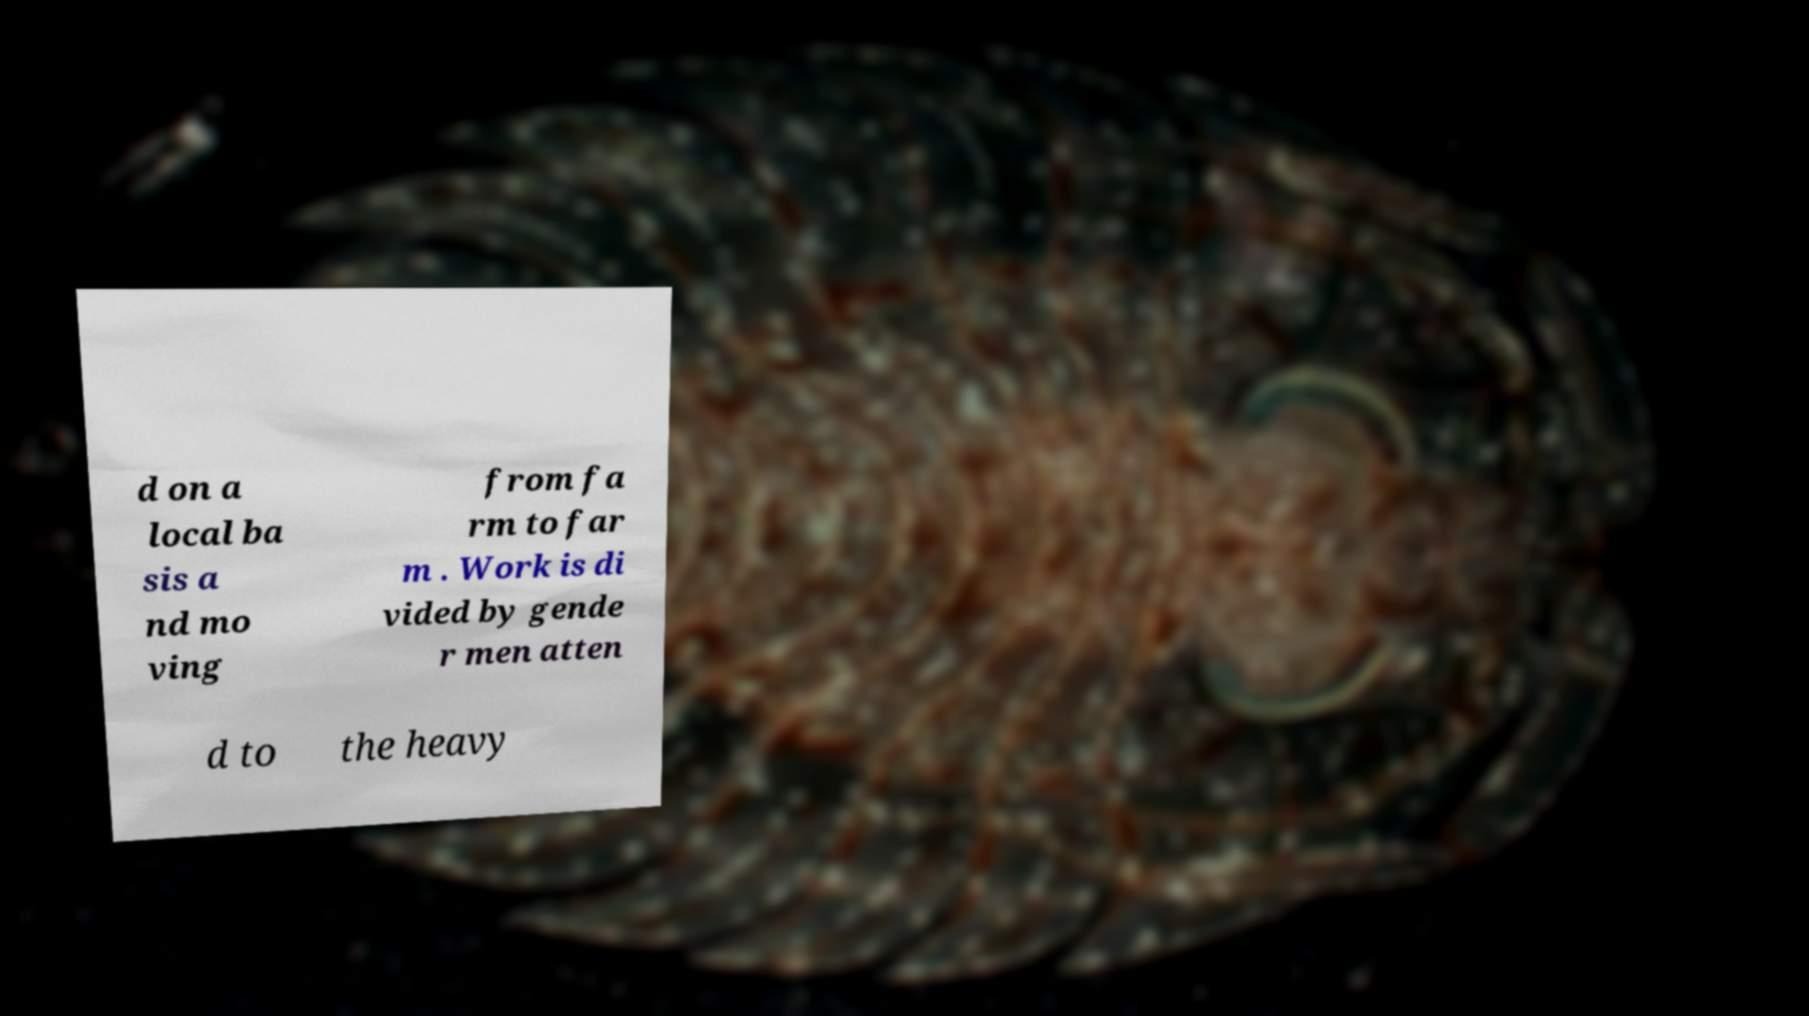What messages or text are displayed in this image? I need them in a readable, typed format. d on a local ba sis a nd mo ving from fa rm to far m . Work is di vided by gende r men atten d to the heavy 